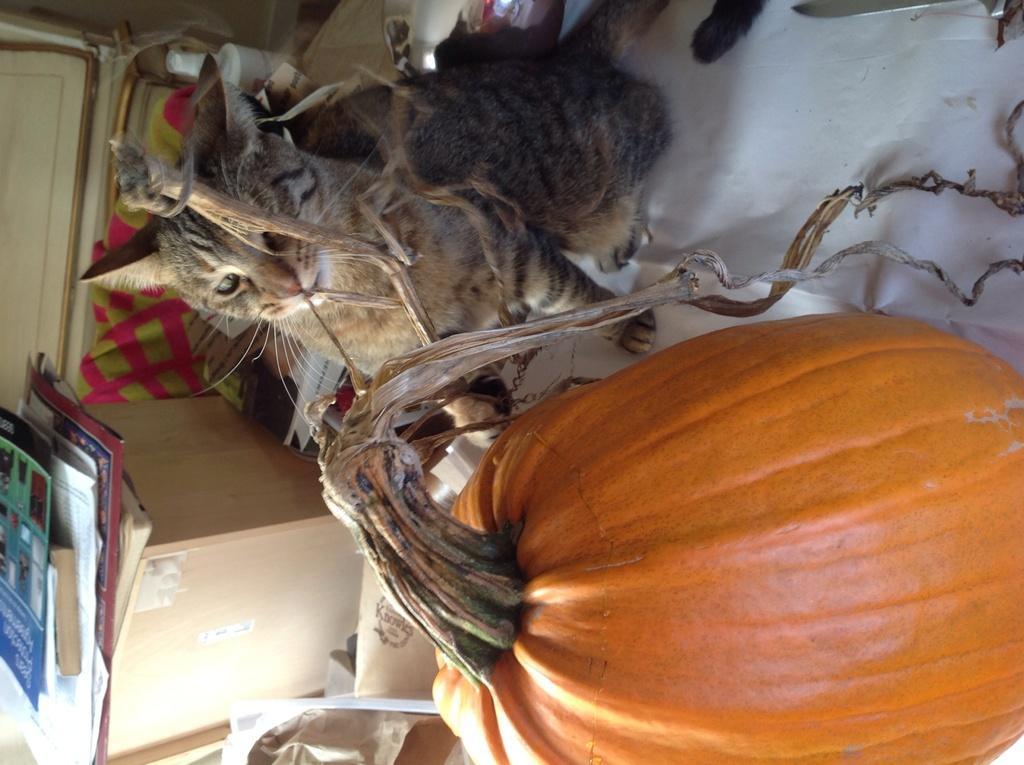Describe this image in one or two sentences. In this picture we can see a cat, pumpkin, box, cloth, books and some objects. 